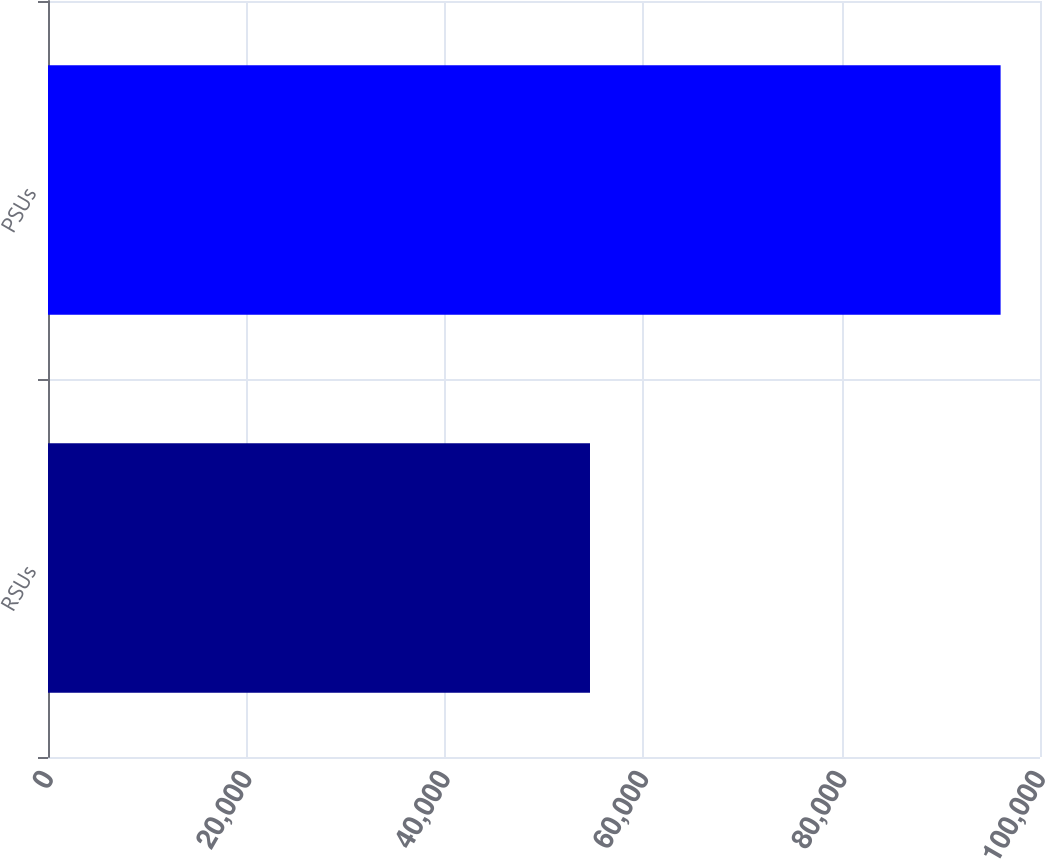<chart> <loc_0><loc_0><loc_500><loc_500><bar_chart><fcel>RSUs<fcel>PSUs<nl><fcel>54637<fcel>96029<nl></chart> 